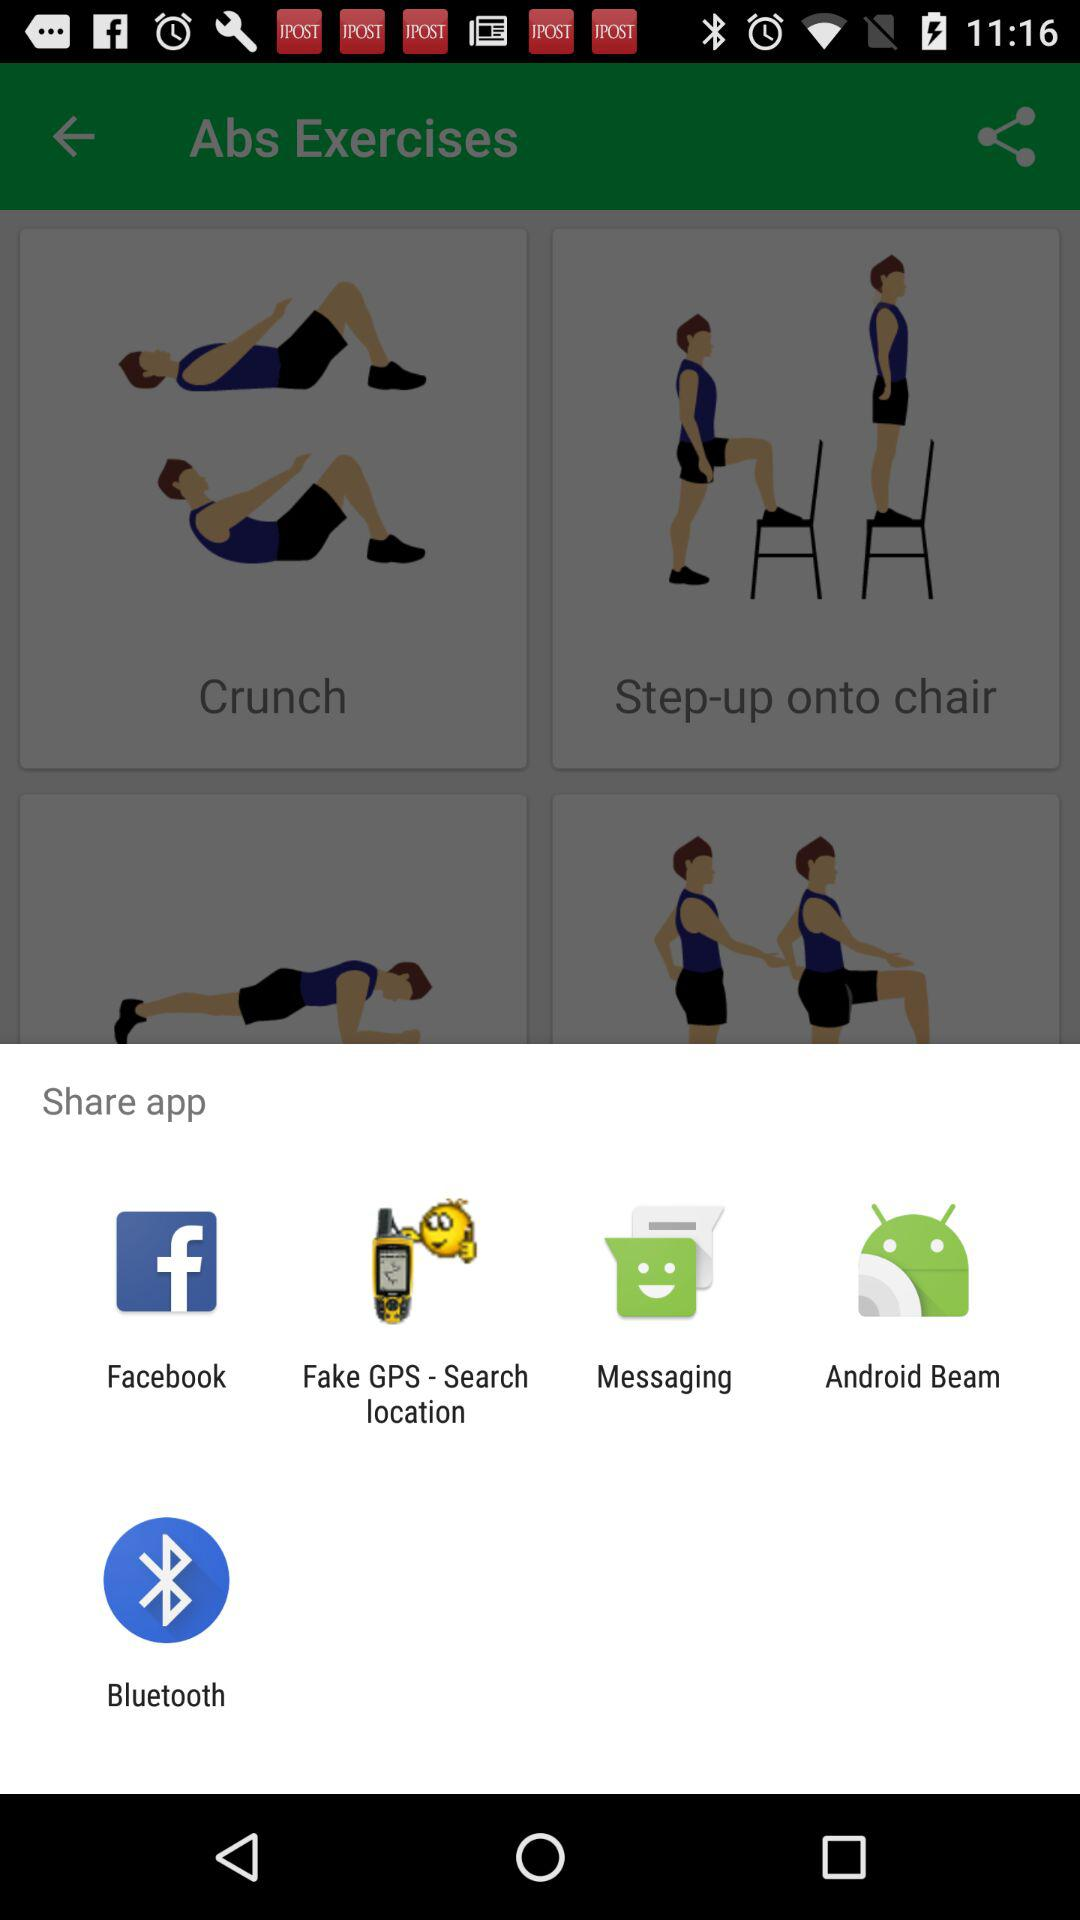Through which app can I share it? You can share it through "Facebook", "Fake GPS - Search location", "Messaging", "Android Beam " and "Bluetooth". 